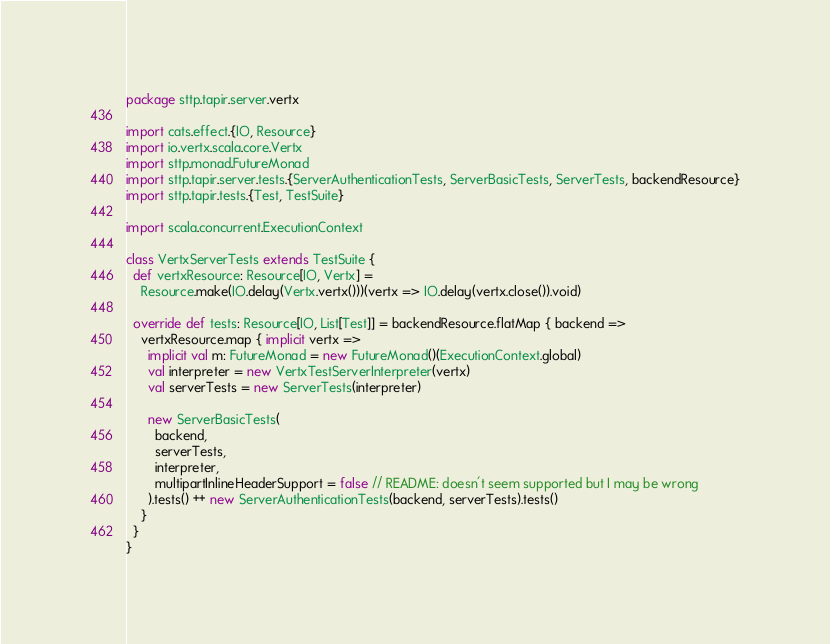Convert code to text. <code><loc_0><loc_0><loc_500><loc_500><_Scala_>package sttp.tapir.server.vertx

import cats.effect.{IO, Resource}
import io.vertx.scala.core.Vertx
import sttp.monad.FutureMonad
import sttp.tapir.server.tests.{ServerAuthenticationTests, ServerBasicTests, ServerTests, backendResource}
import sttp.tapir.tests.{Test, TestSuite}

import scala.concurrent.ExecutionContext

class VertxServerTests extends TestSuite {
  def vertxResource: Resource[IO, Vertx] =
    Resource.make(IO.delay(Vertx.vertx()))(vertx => IO.delay(vertx.close()).void)

  override def tests: Resource[IO, List[Test]] = backendResource.flatMap { backend =>
    vertxResource.map { implicit vertx =>
      implicit val m: FutureMonad = new FutureMonad()(ExecutionContext.global)
      val interpreter = new VertxTestServerInterpreter(vertx)
      val serverTests = new ServerTests(interpreter)

      new ServerBasicTests(
        backend,
        serverTests,
        interpreter,
        multipartInlineHeaderSupport = false // README: doesn't seem supported but I may be wrong
      ).tests() ++ new ServerAuthenticationTests(backend, serverTests).tests()
    }
  }
}
</code> 